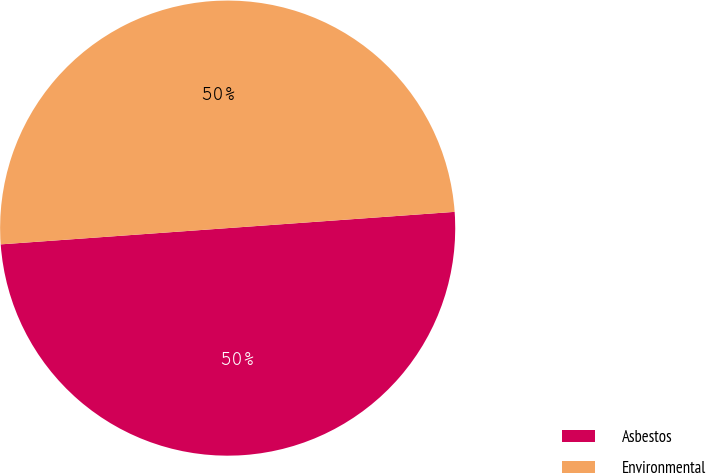Convert chart. <chart><loc_0><loc_0><loc_500><loc_500><pie_chart><fcel>Asbestos<fcel>Environmental<nl><fcel>50.0%<fcel>50.0%<nl></chart> 